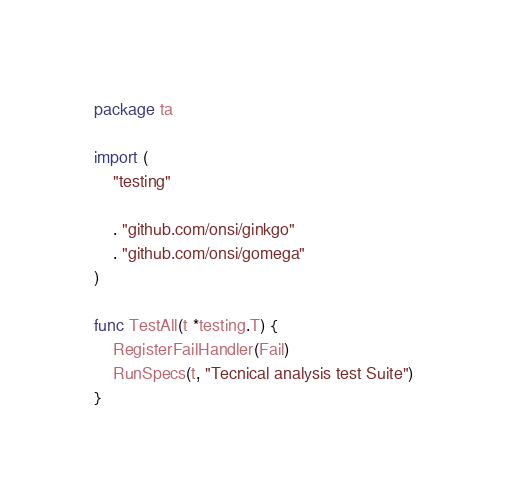<code> <loc_0><loc_0><loc_500><loc_500><_Go_>package ta

import (
	"testing"

	. "github.com/onsi/ginkgo"
	. "github.com/onsi/gomega"
)

func TestAll(t *testing.T) {
	RegisterFailHandler(Fail)
	RunSpecs(t, "Tecnical analysis test Suite")
}
</code> 